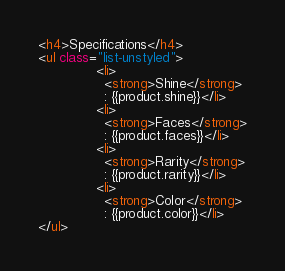<code> <loc_0><loc_0><loc_500><loc_500><_HTML_><h4>Specifications</h4>
<ul class="list-unstyled">
              <li>
                <strong>Shine</strong>
                : {{product.shine}}</li>
              <li>
                <strong>Faces</strong>
                : {{product.faces}}</li>
              <li>
                <strong>Rarity</strong>
                : {{product.rarity}}</li>
              <li>
                <strong>Color</strong>
                : {{product.color}}</li>
</ul> </code> 